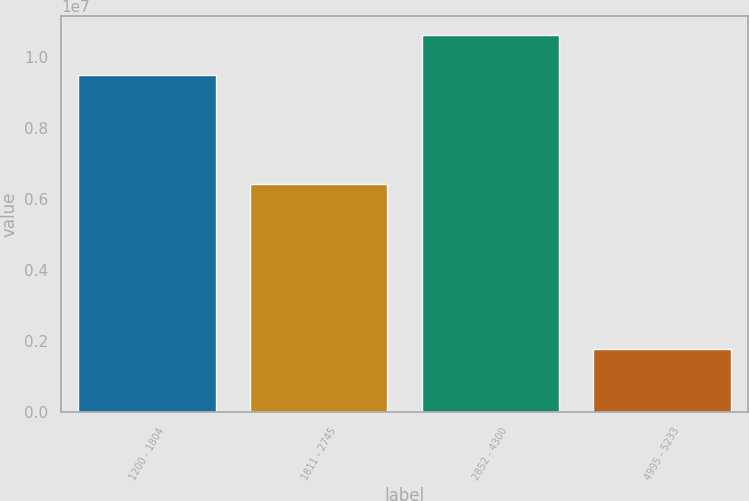Convert chart to OTSL. <chart><loc_0><loc_0><loc_500><loc_500><bar_chart><fcel>1200 - 1804<fcel>1811 - 2745<fcel>2852 - 4300<fcel>4995 - 5233<nl><fcel>9.49699e+06<fcel>6.42886e+06<fcel>1.06149e+07<fcel>1.79173e+06<nl></chart> 